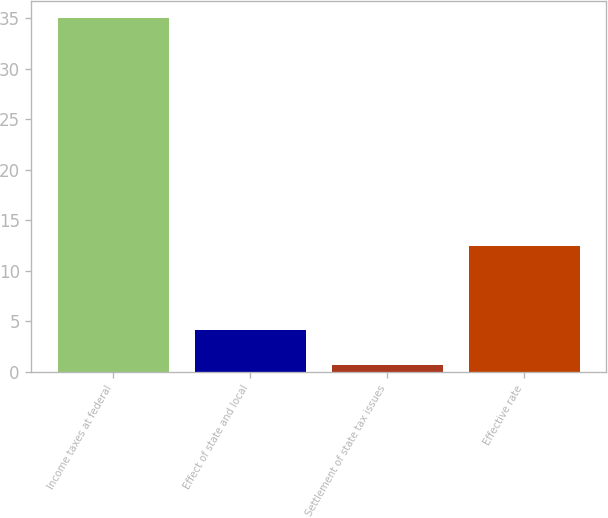Convert chart. <chart><loc_0><loc_0><loc_500><loc_500><bar_chart><fcel>Income taxes at federal<fcel>Effect of state and local<fcel>Settlement of state tax issues<fcel>Effective rate<nl><fcel>35<fcel>4.13<fcel>0.7<fcel>12.4<nl></chart> 